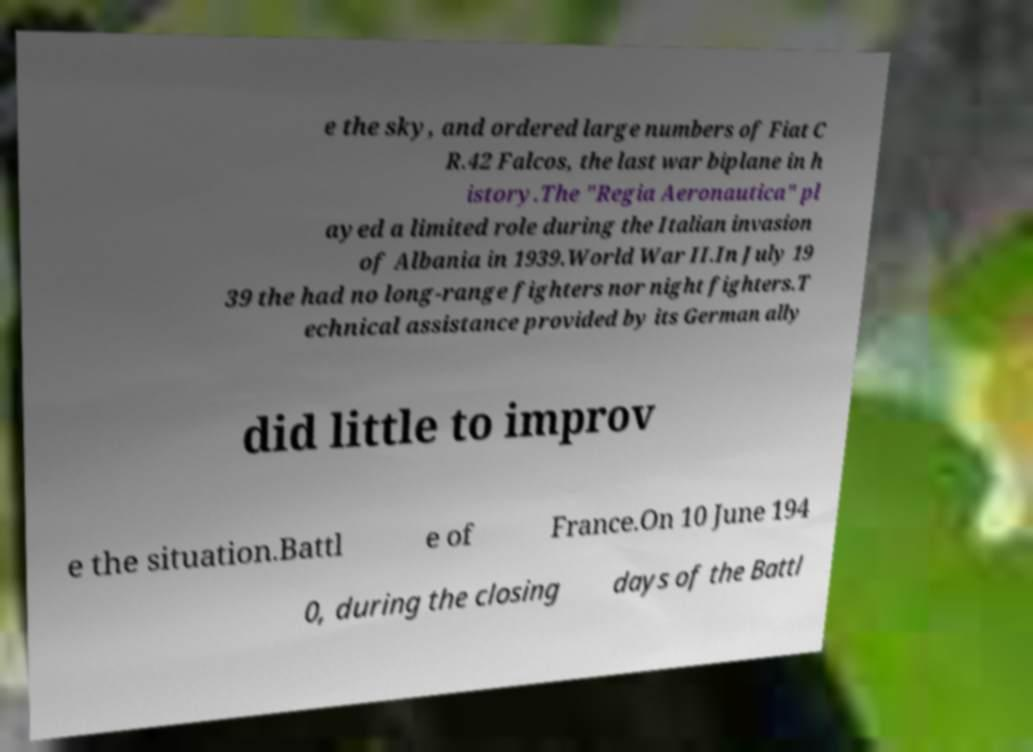Can you accurately transcribe the text from the provided image for me? e the sky, and ordered large numbers of Fiat C R.42 Falcos, the last war biplane in h istory.The "Regia Aeronautica" pl ayed a limited role during the Italian invasion of Albania in 1939.World War II.In July 19 39 the had no long-range fighters nor night fighters.T echnical assistance provided by its German ally did little to improv e the situation.Battl e of France.On 10 June 194 0, during the closing days of the Battl 